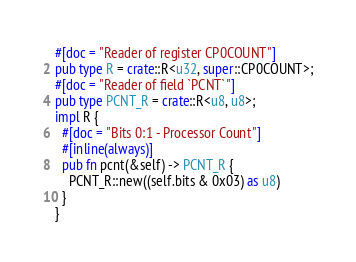Convert code to text. <code><loc_0><loc_0><loc_500><loc_500><_Rust_>#[doc = "Reader of register CP0COUNT"]
pub type R = crate::R<u32, super::CP0COUNT>;
#[doc = "Reader of field `PCNT`"]
pub type PCNT_R = crate::R<u8, u8>;
impl R {
  #[doc = "Bits 0:1 - Processor Count"]
  #[inline(always)]
  pub fn pcnt(&self) -> PCNT_R {
    PCNT_R::new((self.bits & 0x03) as u8)
  }
}
</code> 